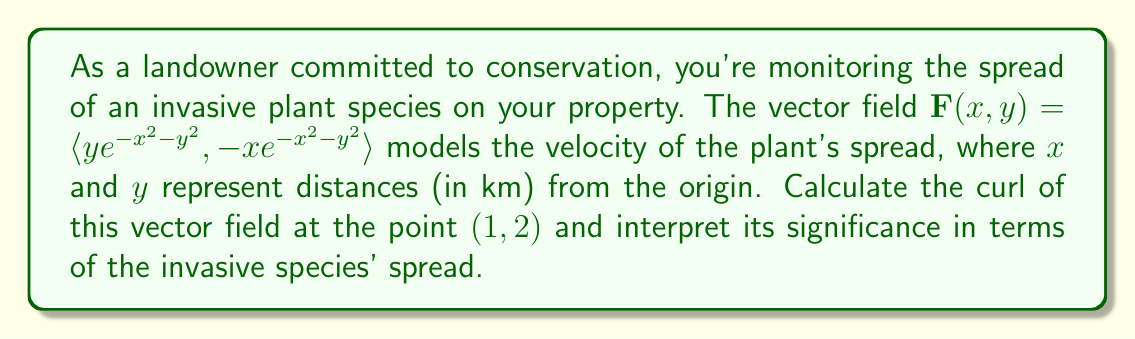Can you solve this math problem? To solve this problem, we'll follow these steps:

1) Recall that the curl of a vector field $\mathbf{F}(x,y) = \langle P(x,y), Q(x,y) \rangle$ in two dimensions is given by:

   $$\text{curl }\mathbf{F} = \frac{\partial Q}{\partial x} - \frac{\partial P}{\partial y}$$

2) In our case, 
   $P(x,y) = ye^{-x^2-y^2}$ and $Q(x,y) = -xe^{-x^2-y^2}$

3) Let's calculate $\frac{\partial Q}{\partial x}$:
   $$\begin{align}
   \frac{\partial Q}{\partial x} &= \frac{\partial}{\partial x}(-xe^{-x^2-y^2}) \\
   &= -e^{-x^2-y^2} + 2x^2e^{-x^2-y^2} \\
   &= e^{-x^2-y^2}(2x^2 - 1)
   \end{align}$$

4) Now, let's calculate $\frac{\partial P}{\partial y}$:
   $$\begin{align}
   \frac{\partial P}{\partial y} &= \frac{\partial}{\partial y}(ye^{-x^2-y^2}) \\
   &= e^{-x^2-y^2} - 2y^2e^{-x^2-y^2} \\
   &= e^{-x^2-y^2}(1 - 2y^2)
   \end{align}$$

5) Now we can calculate the curl:
   $$\begin{align}
   \text{curl }\mathbf{F} &= \frac{\partial Q}{\partial x} - \frac{\partial P}{\partial y} \\
   &= e^{-x^2-y^2}(2x^2 - 1) - e^{-x^2-y^2}(1 - 2y^2) \\
   &= e^{-x^2-y^2}(2x^2 - 1 - 1 + 2y^2) \\
   &= e^{-x^2-y^2}(2x^2 + 2y^2 - 2)
   \end{align}$$

6) At the point (1,2), we have:
   $$\begin{align}
   \text{curl }\mathbf{F}(1,2) &= e^{-1^2-2^2}(2(1)^2 + 2(2)^2 - 2) \\
   &= e^{-5}(2 + 8 - 2) \\
   &= 8e^{-5}
   \end{align}$$

Interpretation: The curl at a point represents the tendency of the vector field to rotate around that point. A positive curl indicates counterclockwise rotation, while a negative curl indicates clockwise rotation. The magnitude of the curl represents the strength of this rotational tendency.

In this case, the curl is positive (8e^(-5) ≈ 0.0054), indicating a weak counterclockwise rotational tendency in the spread of the invasive species at the point (1,2) km from the origin. This suggests that the species might be spreading in a slightly spiral pattern at this location, which could inform your conservation strategies.
Answer: The curl of the vector field at (1,2) is $8e^{-5}$ ≈ 0.0054, indicating a weak counterclockwise rotational tendency in the spread of the invasive species at this location. 